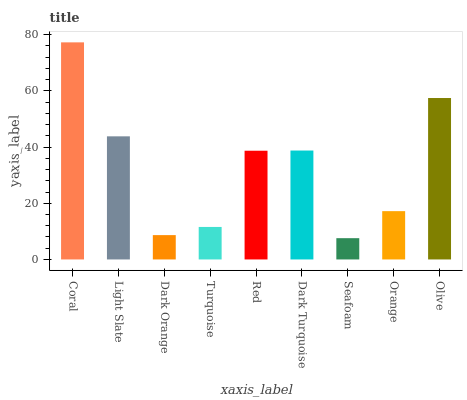Is Seafoam the minimum?
Answer yes or no. Yes. Is Coral the maximum?
Answer yes or no. Yes. Is Light Slate the minimum?
Answer yes or no. No. Is Light Slate the maximum?
Answer yes or no. No. Is Coral greater than Light Slate?
Answer yes or no. Yes. Is Light Slate less than Coral?
Answer yes or no. Yes. Is Light Slate greater than Coral?
Answer yes or no. No. Is Coral less than Light Slate?
Answer yes or no. No. Is Red the high median?
Answer yes or no. Yes. Is Red the low median?
Answer yes or no. Yes. Is Dark Orange the high median?
Answer yes or no. No. Is Dark Turquoise the low median?
Answer yes or no. No. 